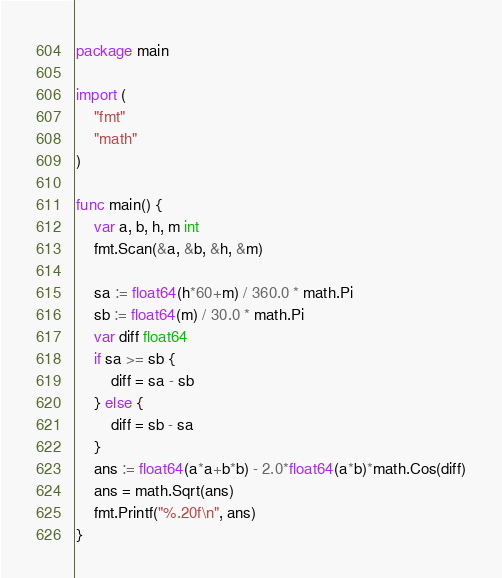Convert code to text. <code><loc_0><loc_0><loc_500><loc_500><_Go_>package main

import (
	"fmt"
	"math"
)

func main() {
	var a, b, h, m int
	fmt.Scan(&a, &b, &h, &m)

	sa := float64(h*60+m) / 360.0 * math.Pi
	sb := float64(m) / 30.0 * math.Pi
	var diff float64
	if sa >= sb {
		diff = sa - sb
	} else {
		diff = sb - sa
	}
	ans := float64(a*a+b*b) - 2.0*float64(a*b)*math.Cos(diff)
	ans = math.Sqrt(ans)
	fmt.Printf("%.20f\n", ans)
}
</code> 